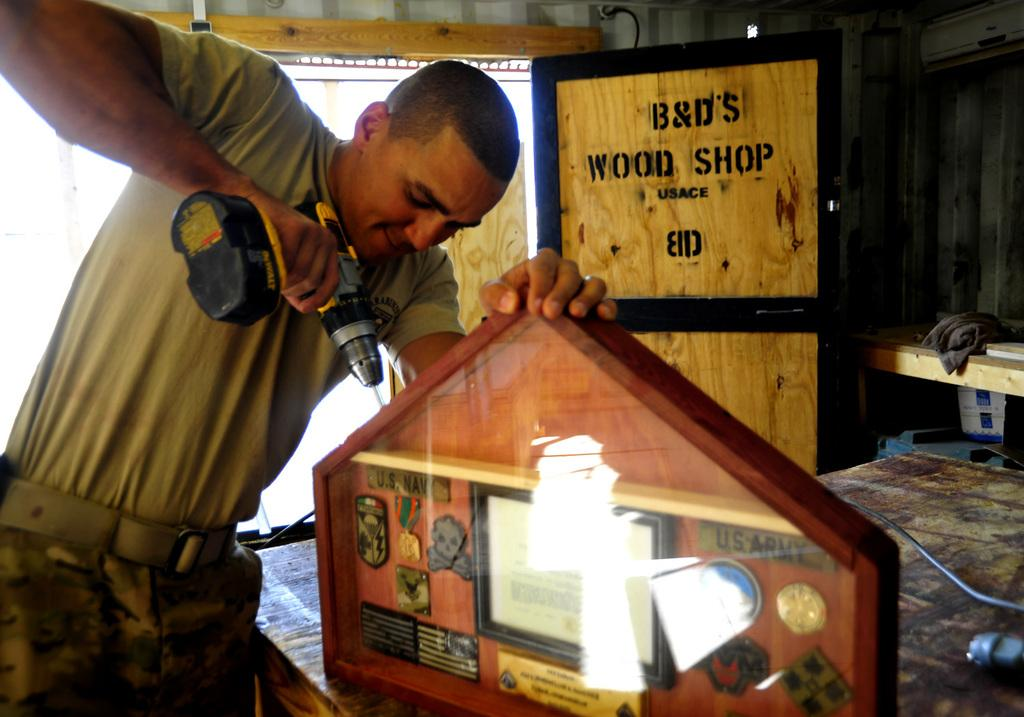<image>
Write a terse but informative summary of the picture. A worker tends to a framed collection of keepsakes in a room known as B & D's Wood Shop. 